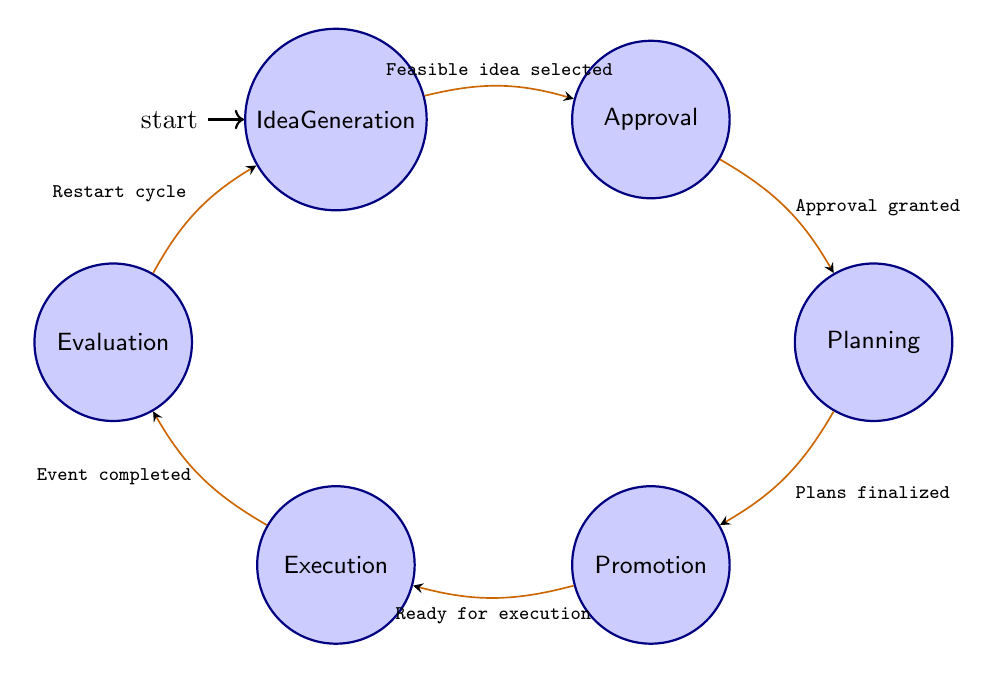What is the first state in the fundraising campaign? The first state in the diagram is labeled "Idea Generation," indicating that this is where the process begins.
Answer: Idea Generation How many states are there in the diagram? By counting each labeled circle in the diagram, we find that there are six states: Idea Generation, Approval, Planning, Promotion, Execution, and Evaluation.
Answer: Six What is the transition from Approval to Planning? The arrow from Approval to Planning is labeled "Approval granted by the school administration," indicating the condition under which this transition occurs.
Answer: Approval granted Which state comes after Execution? Following the Execution state, the next state is Evaluation, as indicated by the arrow leading from Execution to Evaluation.
Answer: Evaluation What condition triggers the transition from Planning to Promotion? The transition from Planning to Promotion is triggered when "Detailed plans and logistics are finalized," as indicated on the arrow connecting these two states.
Answer: Detailed plans and logistics are finalized How does the flow return to the beginning of the campaign? After Evaluation, the flow returns to Idea Generation when the condition "Cycle restarts for next fundraising campaign" is met, as indicated by the arrow pointing back to Idea Generation.
Answer: Cycle restarts What is the last state that follows Promotion? The last state that follows Promotion in the flow is Execution, as shown directly in the diagram by the arrow leading from Promotion to Execution.
Answer: Execution What is the condition for moving from Execution to Evaluation? The condition for transitioning from Execution to Evaluation is marked as "Fundraising event is completed," which must occur for this move to take place.
Answer: Fundraising event is completed What is the relationship between Planning and Promotion states? The relationship is defined by a direct transition where Planning leads to Promotion, marked by the condition "Plans finalized." This shows that Planning must be completed before moving to Promotion.
Answer: Plans finalized 